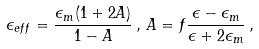<formula> <loc_0><loc_0><loc_500><loc_500>\epsilon _ { e f f } = \frac { \epsilon _ { m } ( 1 + 2 A ) } { 1 - A } \, , \, A = f \frac { \epsilon - \epsilon _ { m } } { \epsilon + 2 \epsilon _ { m } } \, ,</formula> 